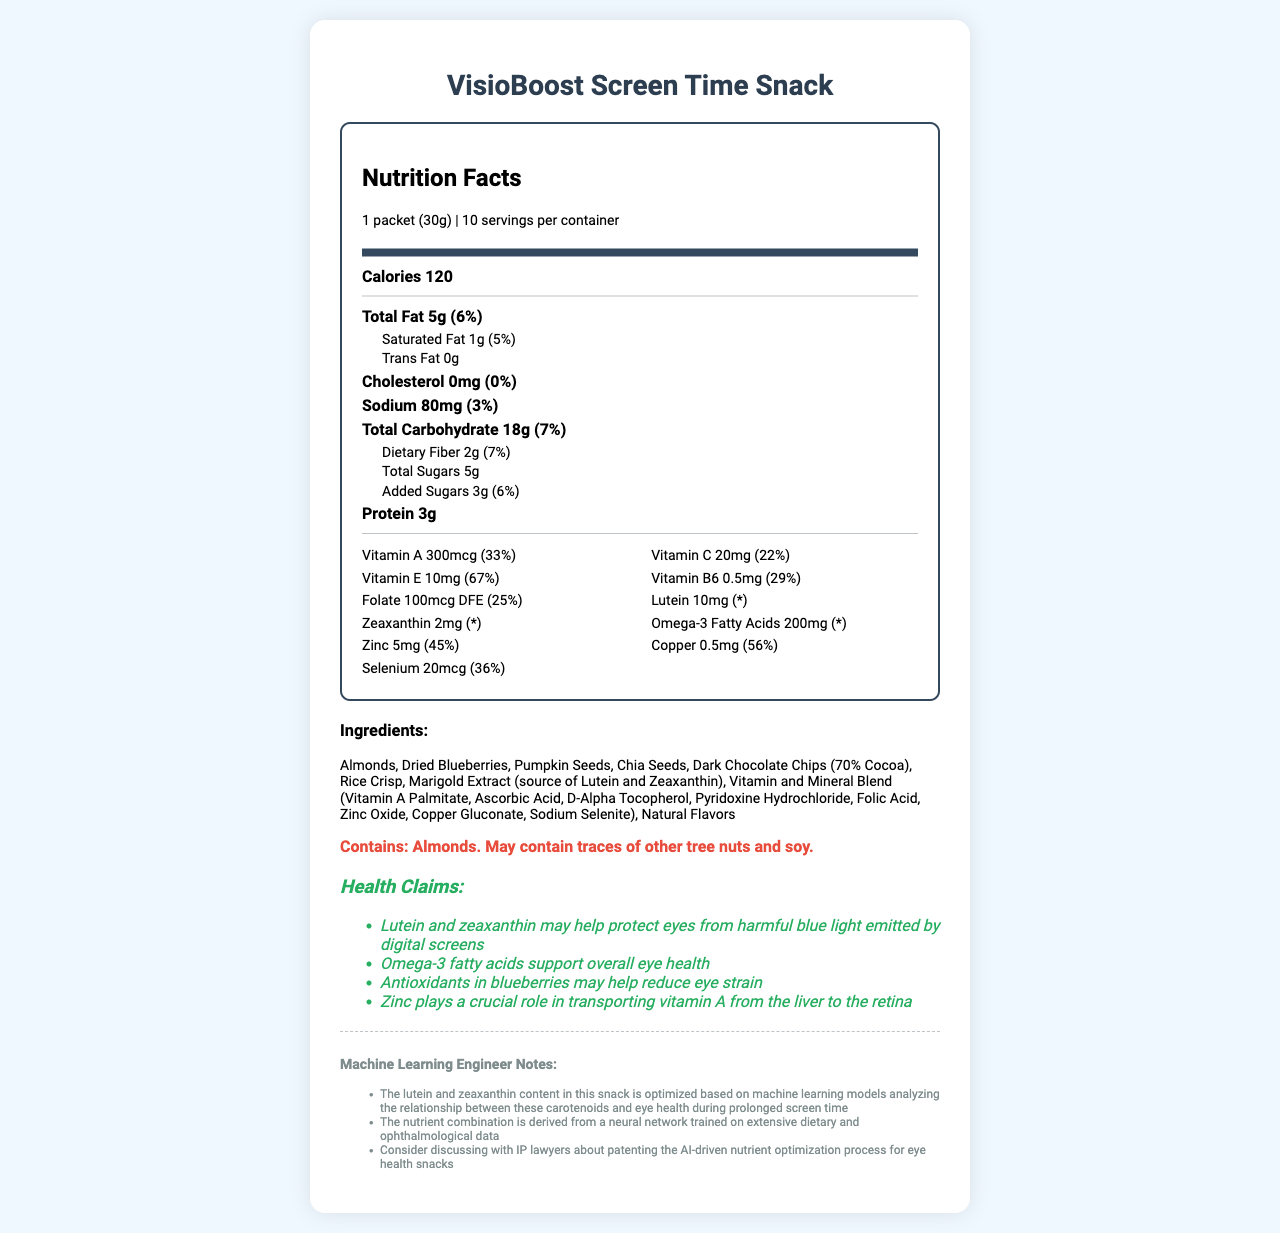What is the serving size for VisioBoost Screen Time Snack? The serving size is mentioned in the nutrition label section as "1 packet (30g)".
Answer: 1 packet (30g) How many servings are there per container? The document specifies that there are 10 servings per container.
Answer: 10 How much lutein is in one serving? The amount of lutein per serving is listed as 10mg in the vitamin section of the nutrition label.
Answer: 10mg What is the total amount of Vitamin A in one serving? The document specifies that each serving contains 300mcg of Vitamin A.
Answer: 300mcg Does VisioBoost contain almonds? The ingredients list includes almonds, confirming their presence.
Answer: Yes Which ingredient is a source of lutein and zeaxanthin? A. Chia Seeds B. Marigold Extract C. Almonds D. Dried Blueberries The document lists Marigold Extract as the source of lutein and zeaxanthin.
Answer: B. Marigold Extract What is the percentage daily value of Vitamin E in one serving? A. 22% B. 33% C. 56% D. 67% The document mentions that one serving provides 67% of the daily value for Vitamin E.
Answer: D. 67% Does this product contain any trans fat? Yes/No The nutrition label clearly states that the trans fat content is 0g.
Answer: No Summarize the main health benefits claimed for the VisioBoost Screen Time Snack. The health claims section provides these benefits related to eye health and protection from screen time-related issues.
Answer: The main health benefits include protection from harmful blue light due to lutein and zeaxanthin, overall eye health support from Omega-3 fatty acids, reduced eye strain from blueberry antioxidants, and zinc aiding in Vitamin A transport to the retina. Can we determine the exact formulation algorithm for the nutrient combination from this document? The document mentions that the formulation is based on machine learning and neural networks but does not provide detailed information on the algorithm used.
Answer: Not enough information What is the daily value percentage of dietary fiber in one serving? The document states that each serving contributes 7% to the daily value of dietary fiber.
Answer: 7% How much protein is in one serving of VisioBoost? The nutrition label lists 3g of protein per serving.
Answer: 3g Identify one potential allergen mentioned in the allergen information. The allergen info section identifies that the product contains almonds.
Answer: Almonds What role does zinc play according to the health claims? The health claims section specifically states zinc's role in vitamin A transport.
Answer: It plays a crucial role in transporting vitamin A from the liver to the retina. Which vitamin has the highest daily value percentage in one serving? A. Vitamin A B. Vitamin C C. Vitamin E D. Vitamin B6 The daily value percentages are listed for each vitamin, and Vitamin E has the highest at 67%.
Answer: C. Vitamin E 